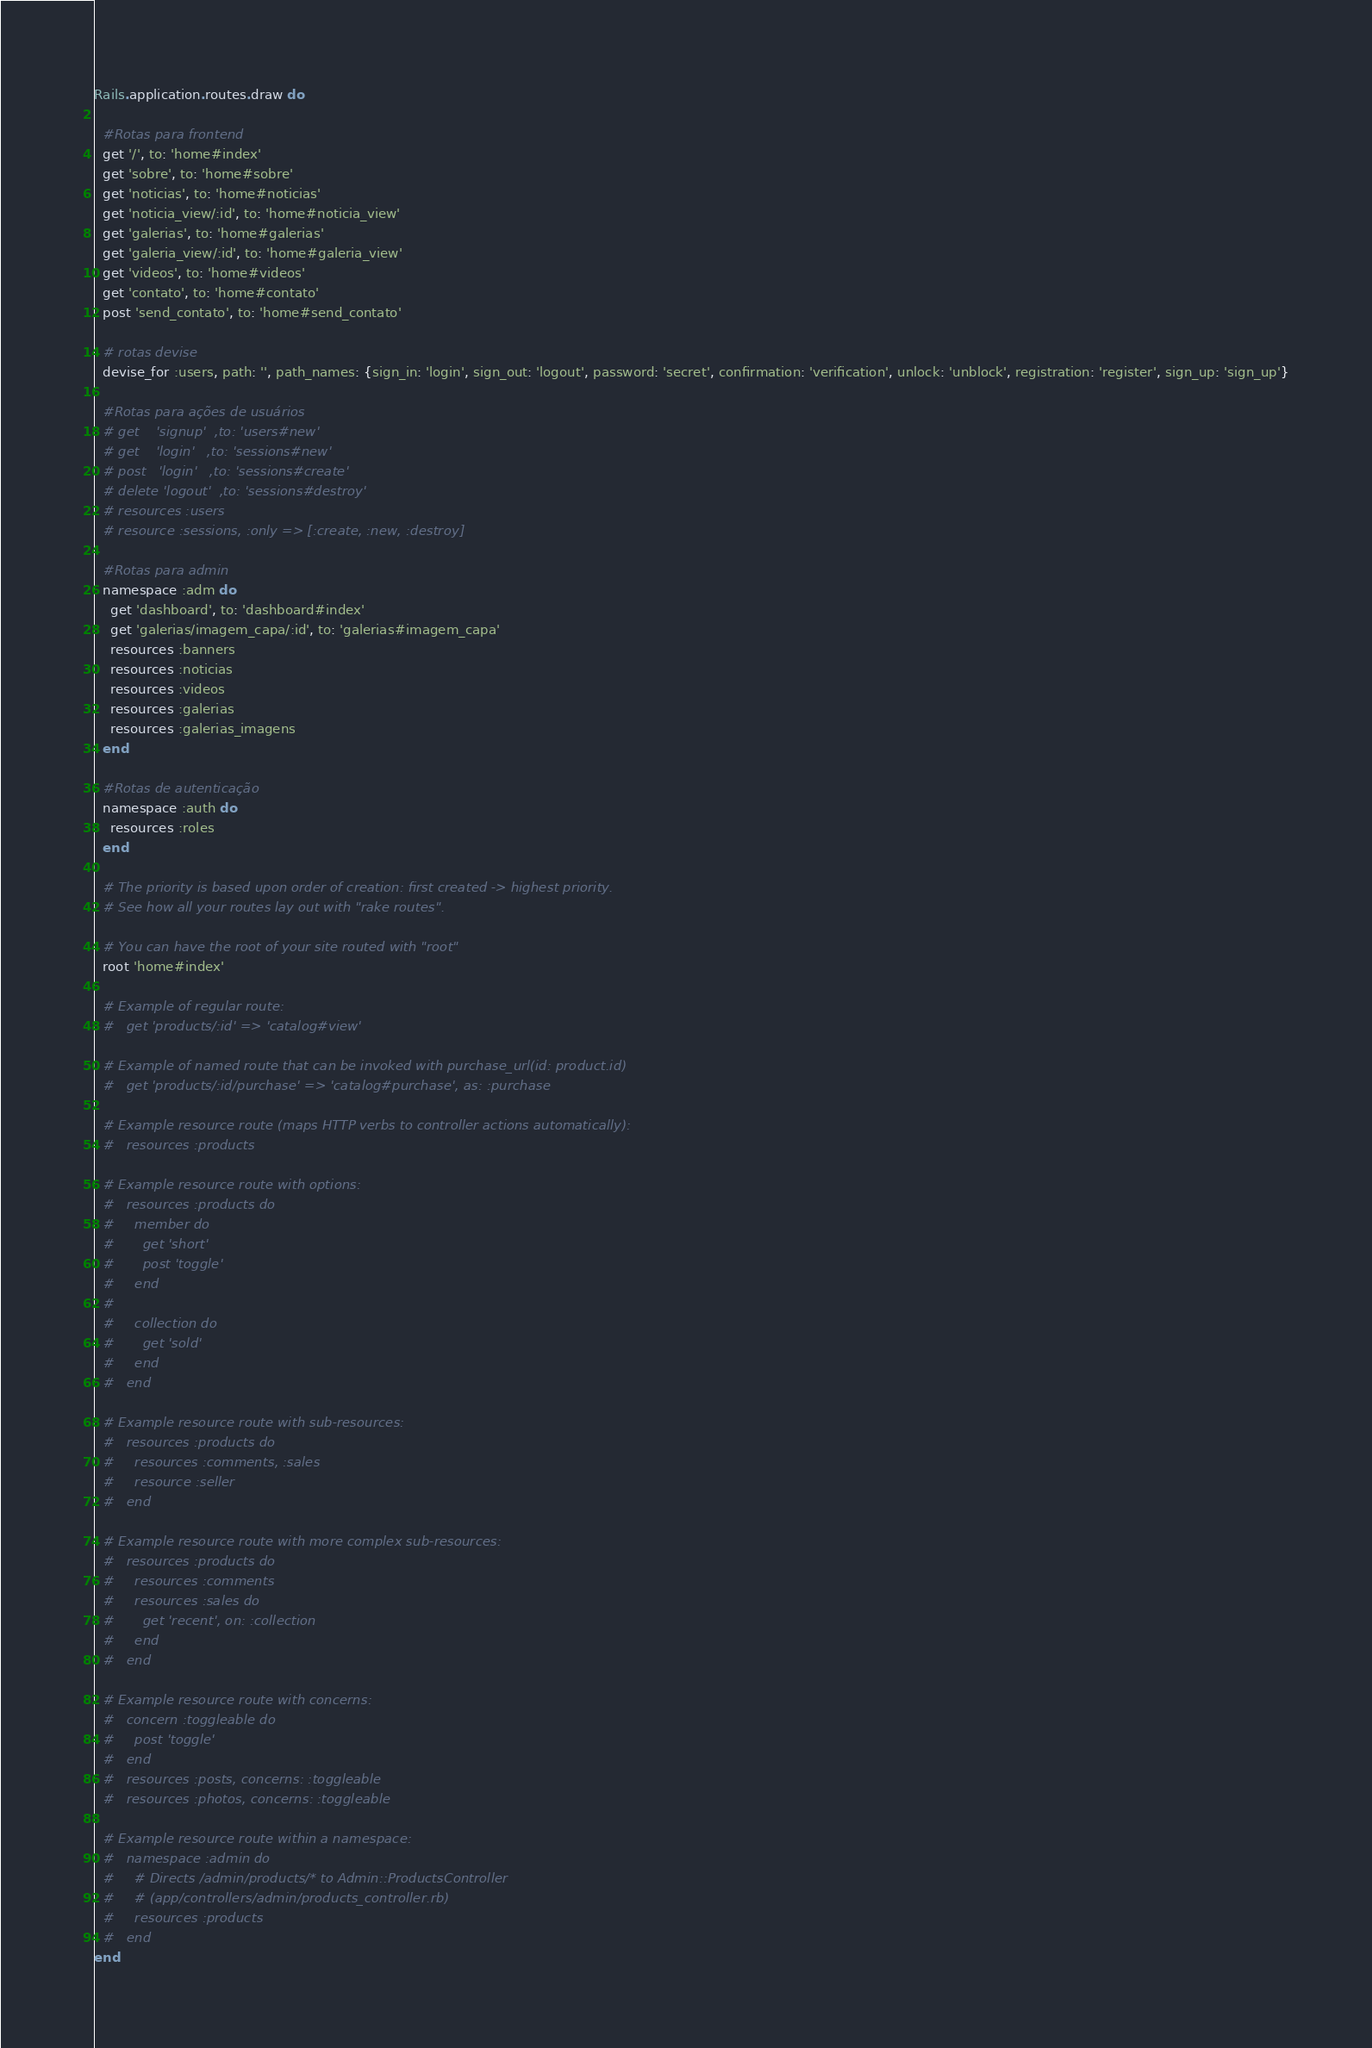<code> <loc_0><loc_0><loc_500><loc_500><_Ruby_>Rails.application.routes.draw do

  #Rotas para frontend
  get '/', to: 'home#index'
  get 'sobre', to: 'home#sobre'
  get 'noticias', to: 'home#noticias'
  get 'noticia_view/:id', to: 'home#noticia_view'
  get 'galerias', to: 'home#galerias'
  get 'galeria_view/:id', to: 'home#galeria_view'
  get 'videos', to: 'home#videos'
  get 'contato', to: 'home#contato'
  post 'send_contato', to: 'home#send_contato'

  # rotas devise
  devise_for :users, path: '', path_names: {sign_in: 'login', sign_out: 'logout', password: 'secret', confirmation: 'verification', unlock: 'unblock', registration: 'register', sign_up: 'sign_up'}

  #Rotas para ações de usuários
  # get    'signup'  ,to: 'users#new'
  # get    'login'   ,to: 'sessions#new'
  # post   'login'   ,to: 'sessions#create'
  # delete 'logout'  ,to: 'sessions#destroy'
  # resources :users
  # resource :sessions, :only => [:create, :new, :destroy]

  #Rotas para admin
  namespace :adm do
    get 'dashboard', to: 'dashboard#index'
    get 'galerias/imagem_capa/:id', to: 'galerias#imagem_capa'
    resources :banners
    resources :noticias
    resources :videos
    resources :galerias
    resources :galerias_imagens
  end

  #Rotas de autenticação
  namespace :auth do
    resources :roles
  end

  # The priority is based upon order of creation: first created -> highest priority.
  # See how all your routes lay out with "rake routes".

  # You can have the root of your site routed with "root"
  root 'home#index'

  # Example of regular route:
  #   get 'products/:id' => 'catalog#view'

  # Example of named route that can be invoked with purchase_url(id: product.id)
  #   get 'products/:id/purchase' => 'catalog#purchase', as: :purchase

  # Example resource route (maps HTTP verbs to controller actions automatically):
  #   resources :products

  # Example resource route with options:
  #   resources :products do
  #     member do
  #       get 'short'
  #       post 'toggle'
  #     end
  #
  #     collection do
  #       get 'sold'
  #     end
  #   end

  # Example resource route with sub-resources:
  #   resources :products do
  #     resources :comments, :sales
  #     resource :seller
  #   end

  # Example resource route with more complex sub-resources:
  #   resources :products do
  #     resources :comments
  #     resources :sales do
  #       get 'recent', on: :collection
  #     end
  #   end

  # Example resource route with concerns:
  #   concern :toggleable do
  #     post 'toggle'
  #   end
  #   resources :posts, concerns: :toggleable
  #   resources :photos, concerns: :toggleable

  # Example resource route within a namespace:
  #   namespace :admin do
  #     # Directs /admin/products/* to Admin::ProductsController
  #     # (app/controllers/admin/products_controller.rb)
  #     resources :products
  #   end
end
</code> 